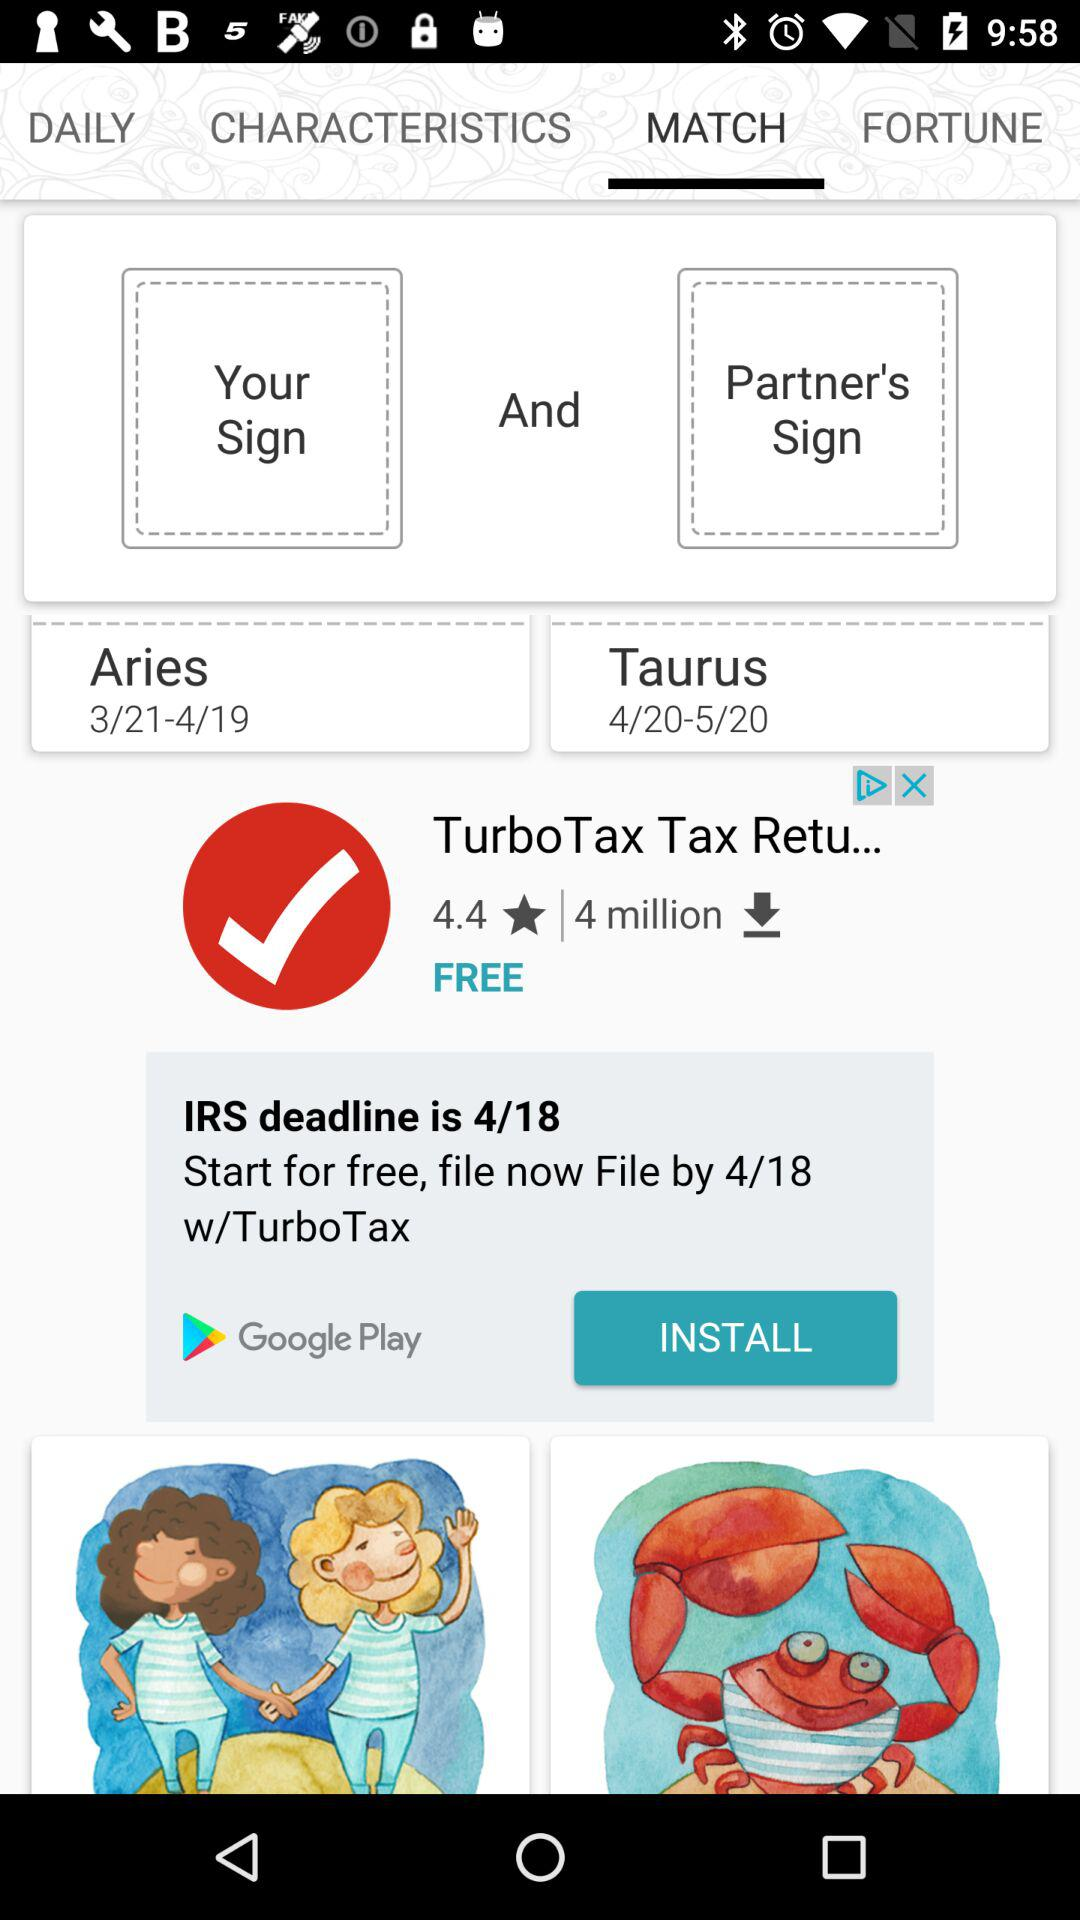What is the selected tab? The selected tab is "MATCH". 